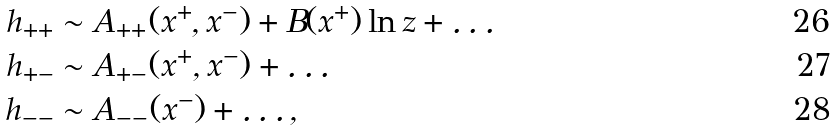<formula> <loc_0><loc_0><loc_500><loc_500>h _ { + + } & \sim A _ { + + } ( x ^ { + } , x ^ { - } ) + B ( x ^ { + } ) \ln z + \dots \\ h _ { + - } & \sim A _ { + - } ( x ^ { + } , x ^ { - } ) + \dots \\ h _ { - - } & \sim A _ { - - } ( x ^ { - } ) + \dots ,</formula> 